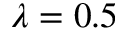Convert formula to latex. <formula><loc_0><loc_0><loc_500><loc_500>\lambda = 0 . 5</formula> 